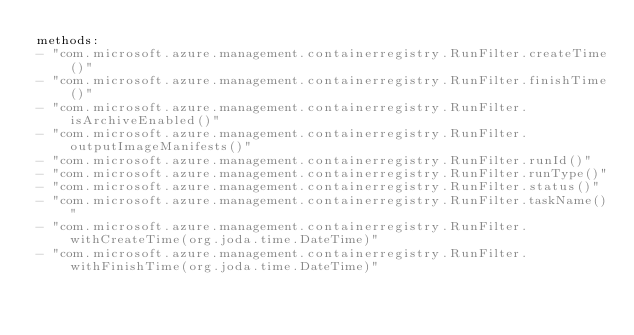Convert code to text. <code><loc_0><loc_0><loc_500><loc_500><_YAML_>methods:
- "com.microsoft.azure.management.containerregistry.RunFilter.createTime()"
- "com.microsoft.azure.management.containerregistry.RunFilter.finishTime()"
- "com.microsoft.azure.management.containerregistry.RunFilter.isArchiveEnabled()"
- "com.microsoft.azure.management.containerregistry.RunFilter.outputImageManifests()"
- "com.microsoft.azure.management.containerregistry.RunFilter.runId()"
- "com.microsoft.azure.management.containerregistry.RunFilter.runType()"
- "com.microsoft.azure.management.containerregistry.RunFilter.status()"
- "com.microsoft.azure.management.containerregistry.RunFilter.taskName()"
- "com.microsoft.azure.management.containerregistry.RunFilter.withCreateTime(org.joda.time.DateTime)"
- "com.microsoft.azure.management.containerregistry.RunFilter.withFinishTime(org.joda.time.DateTime)"</code> 